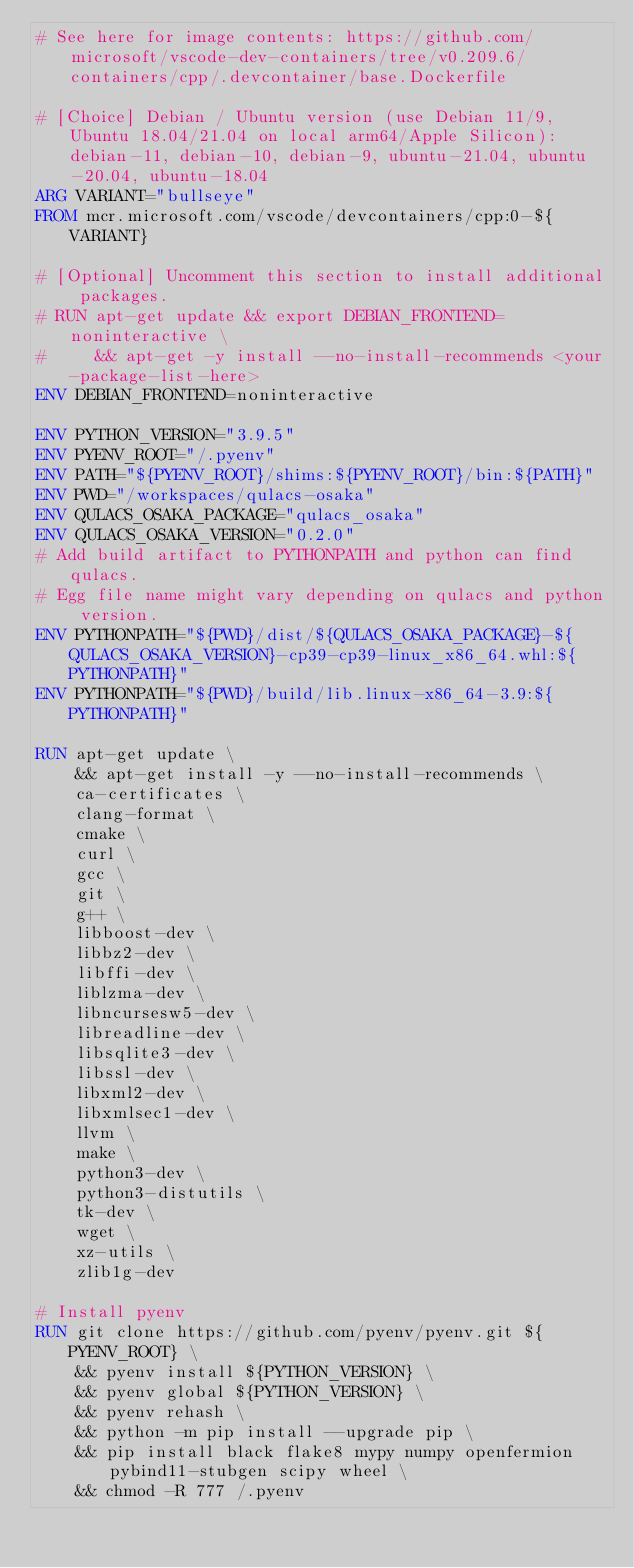<code> <loc_0><loc_0><loc_500><loc_500><_Dockerfile_># See here for image contents: https://github.com/microsoft/vscode-dev-containers/tree/v0.209.6/containers/cpp/.devcontainer/base.Dockerfile

# [Choice] Debian / Ubuntu version (use Debian 11/9, Ubuntu 18.04/21.04 on local arm64/Apple Silicon): debian-11, debian-10, debian-9, ubuntu-21.04, ubuntu-20.04, ubuntu-18.04
ARG VARIANT="bullseye"
FROM mcr.microsoft.com/vscode/devcontainers/cpp:0-${VARIANT}

# [Optional] Uncomment this section to install additional packages.
# RUN apt-get update && export DEBIAN_FRONTEND=noninteractive \
#     && apt-get -y install --no-install-recommends <your-package-list-here>
ENV DEBIAN_FRONTEND=noninteractive

ENV PYTHON_VERSION="3.9.5"
ENV PYENV_ROOT="/.pyenv"
ENV PATH="${PYENV_ROOT}/shims:${PYENV_ROOT}/bin:${PATH}"
ENV PWD="/workspaces/qulacs-osaka"
ENV QULACS_OSAKA_PACKAGE="qulacs_osaka"
ENV QULACS_OSAKA_VERSION="0.2.0"
# Add build artifact to PYTHONPATH and python can find qulacs.
# Egg file name might vary depending on qulacs and python version.
ENV PYTHONPATH="${PWD}/dist/${QULACS_OSAKA_PACKAGE}-${QULACS_OSAKA_VERSION}-cp39-cp39-linux_x86_64.whl:${PYTHONPATH}"
ENV PYTHONPATH="${PWD}/build/lib.linux-x86_64-3.9:${PYTHONPATH}"

RUN apt-get update \
    && apt-get install -y --no-install-recommends \
    ca-certificates \
    clang-format \
    cmake \
    curl \
    gcc \
    git \
    g++ \
    libboost-dev \
    libbz2-dev \
    libffi-dev \
    liblzma-dev \
    libncursesw5-dev \
    libreadline-dev \
    libsqlite3-dev \
    libssl-dev \
    libxml2-dev \
    libxmlsec1-dev \
    llvm \
    make \
    python3-dev \
    python3-distutils \
    tk-dev \
    wget \
    xz-utils \
    zlib1g-dev

# Install pyenv
RUN git clone https://github.com/pyenv/pyenv.git ${PYENV_ROOT} \
    && pyenv install ${PYTHON_VERSION} \
    && pyenv global ${PYTHON_VERSION} \
    && pyenv rehash \
    && python -m pip install --upgrade pip \
    && pip install black flake8 mypy numpy openfermion pybind11-stubgen scipy wheel \
    && chmod -R 777 /.pyenv
</code> 